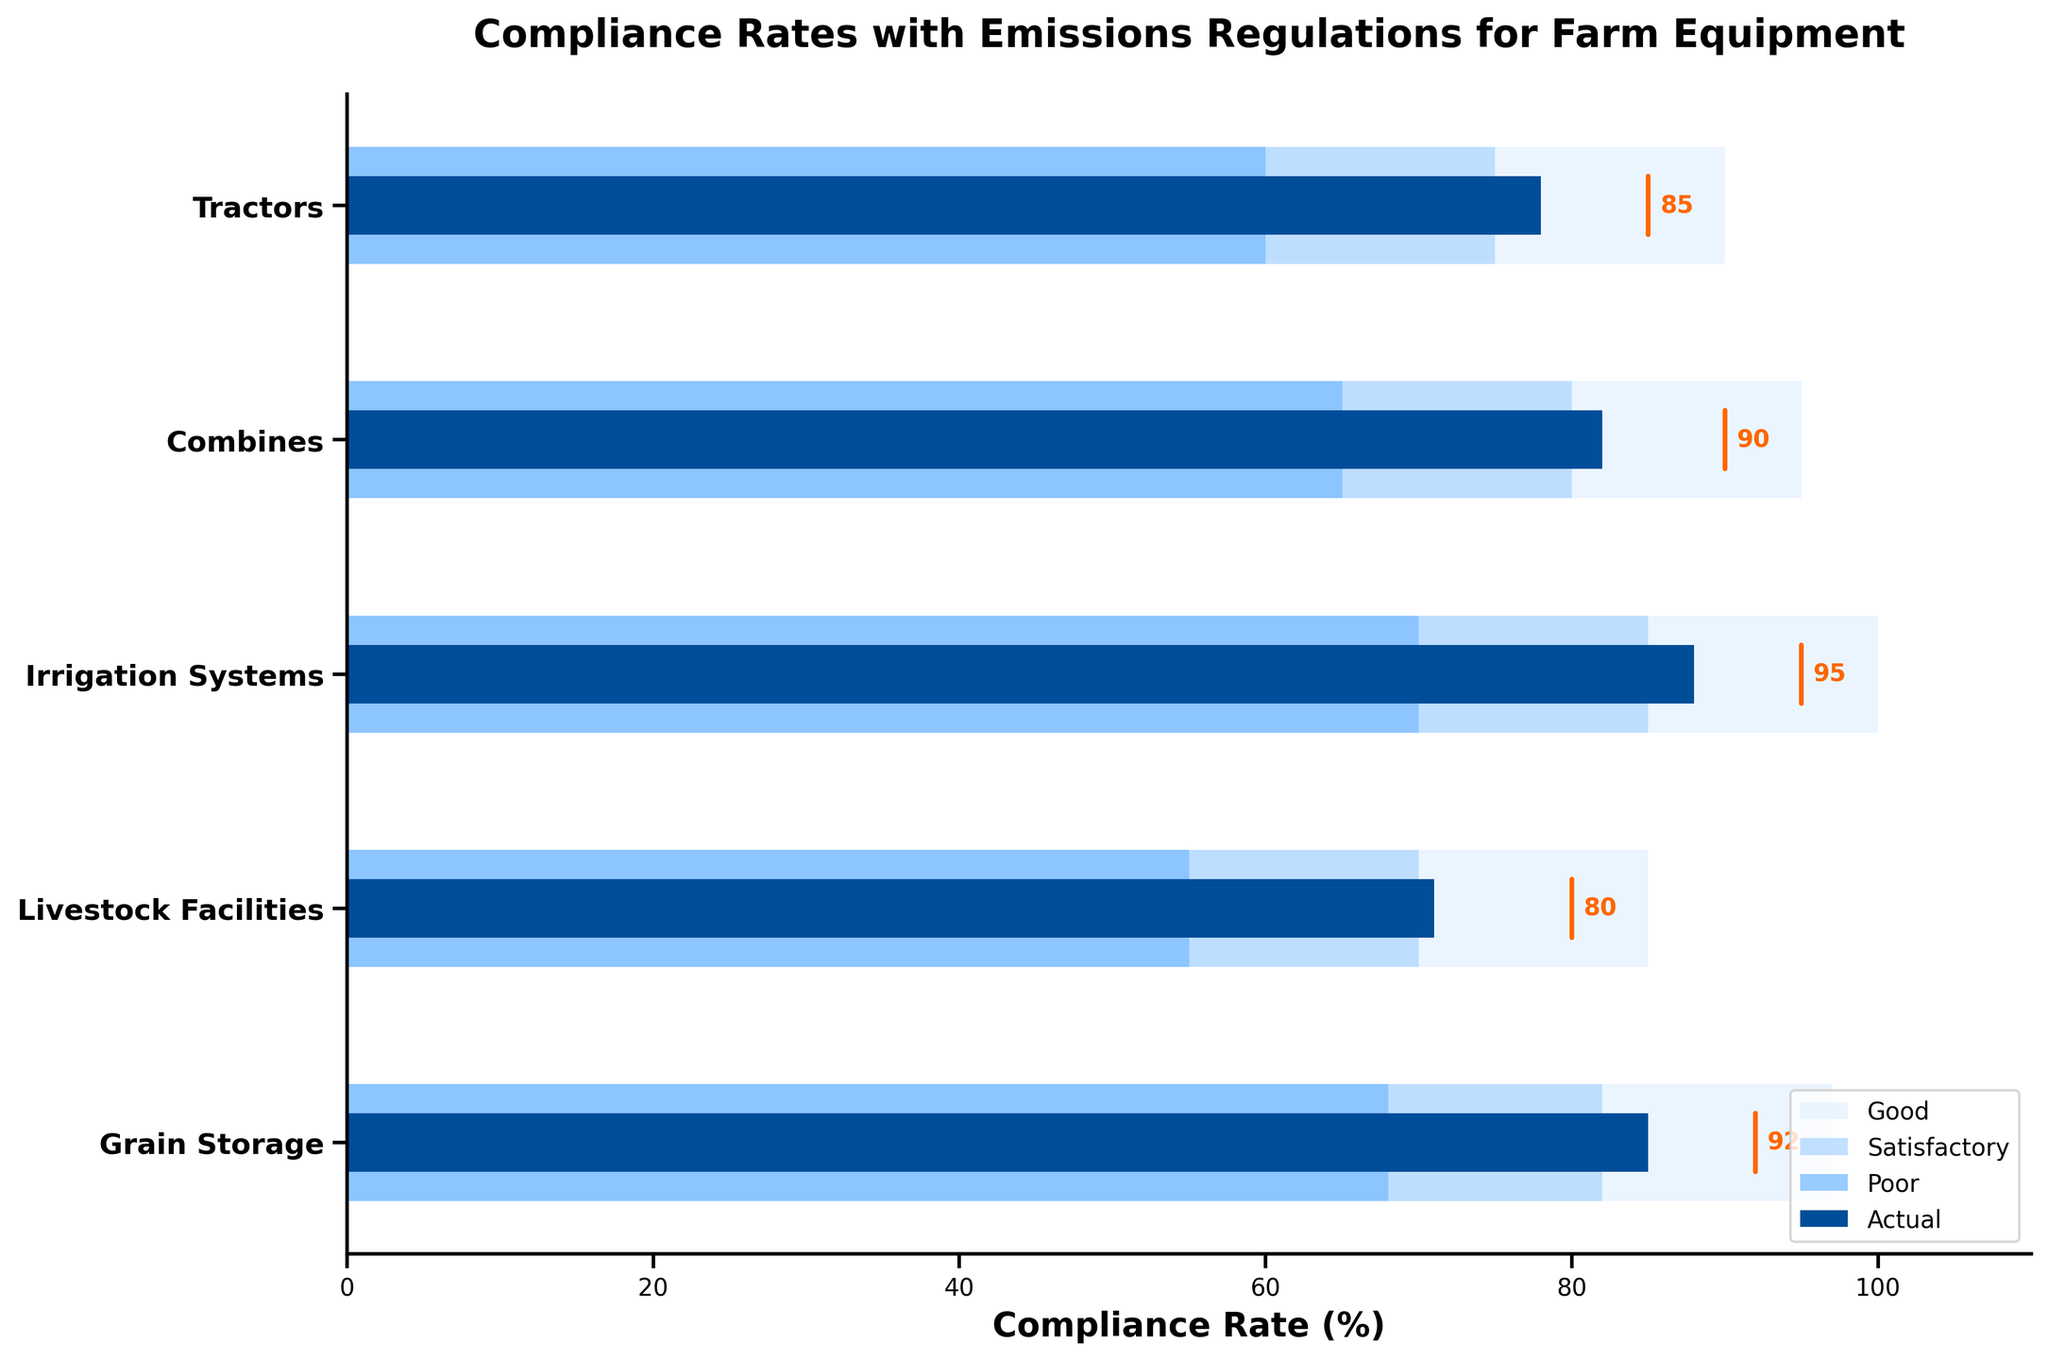How many categories are evaluated in the plot? There are five rows in the data, corresponding each to a category being evaluated in the plot. By identifying each row, we determine there are five categories.
Answer: 5 Which category has the highest actual compliance rate? By looking at the 'Actual' bars for each category, we see that "Irrigation Systems" has the highest bar value of 88%.
Answer: Irrigation Systems What is the target compliance rate for Grain Storage? The plot highlights the target compliance rate near the actual bar for each category. For "Grain Storage," the target is marked as 92.
Answer: 92 Which category has the largest discrepancy between the actual compliance rate and the target compliance rate? To find the largest discrepancy, we calculate the difference between the actual and target for each category: Tractors (85-78), Combines (90-82), Irrigation Systems (95-88), Livestock Facilities (80-71), Grain Storage (92-85). The largest difference is for "Livestock Facilities" at 9%.
Answer: Livestock Facilities What is the average ‘Good’ compliance rate threshold across all categories? To compute the average, sum all 'Good' values and divide by the number of categories: (90 + 95 + 100 + 85 + 97) / 5 = 93.4.
Answer: 93.4 Do any categories have an actual compliance rate that exceeds the ‘Good’ compliance rate threshold? By comparing actual compliance rates to the 'Good' thresholds: Tractors (78<90), Combines (82<95), Irrigation Systems (88<100), Livestock Facilities (71<85), Grain Storage (85<97), we see that no actual compliance rates exceed the ‘Good’ thresholds.
Answer: No Which equipment category is closest to meeting its target compliance rate? Calculate the absolute difference between the actual and target for each category: Tractors (7), Combines (8), Irrigation Systems (7), Livestock Facilities (9), Grain Storage (7). The categories with the smallest difference are "Tractors", "Irrigation Systems", and "Grain Storage," each with a difference of 7.
Answer: Tractors, Irrigation Systems, Grain Storage What range is used to mark a ‘Poor’ compliance rate for Livestock Facilities? By identifying the bars' stacked level for Livestock Facilities, the 'Poor' range is between 55 and 70%.
Answer: 55 to 70 Which categories fall into the 'Satisfactory' compliance rate range but not the 'Good' range? By observing the bars and their shades for each category, we see that "Tractors," "Combines," and "Grain Storage" have actual rates falling into 'Satisfactory' but not 'Good' thresholds.
Answer: Tractors, Combines, Grain Storage 